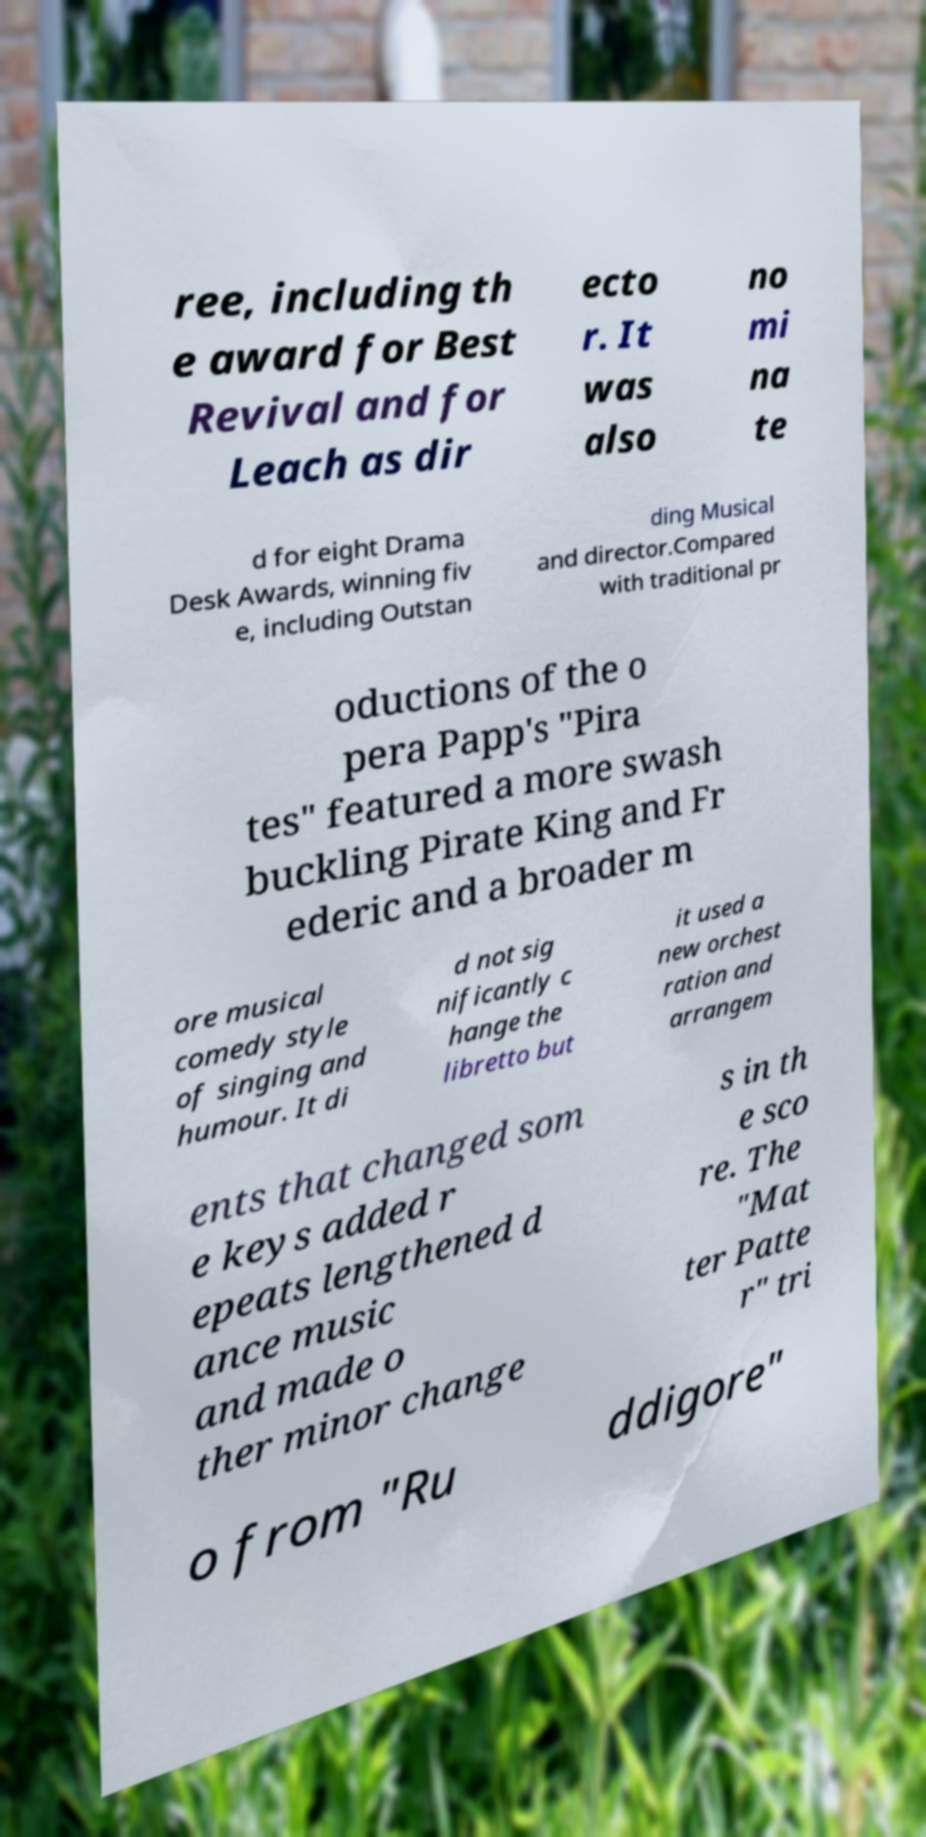Can you accurately transcribe the text from the provided image for me? ree, including th e award for Best Revival and for Leach as dir ecto r. It was also no mi na te d for eight Drama Desk Awards, winning fiv e, including Outstan ding Musical and director.Compared with traditional pr oductions of the o pera Papp's "Pira tes" featured a more swash buckling Pirate King and Fr ederic and a broader m ore musical comedy style of singing and humour. It di d not sig nificantly c hange the libretto but it used a new orchest ration and arrangem ents that changed som e keys added r epeats lengthened d ance music and made o ther minor change s in th e sco re. The "Mat ter Patte r" tri o from "Ru ddigore" 